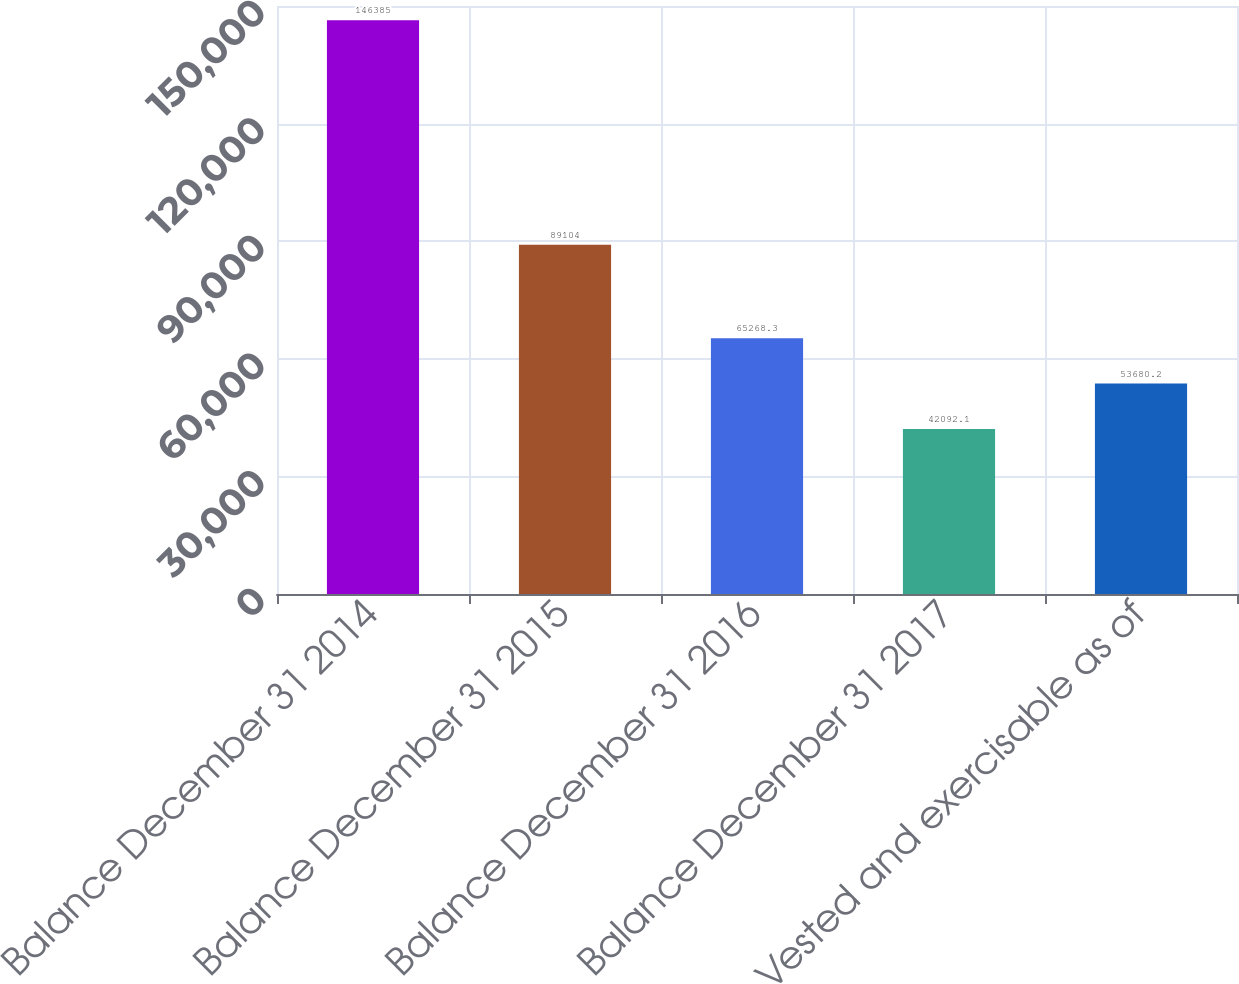<chart> <loc_0><loc_0><loc_500><loc_500><bar_chart><fcel>Balance December 31 2014<fcel>Balance December 31 2015<fcel>Balance December 31 2016<fcel>Balance December 31 2017<fcel>Vested and exercisable as of<nl><fcel>146385<fcel>89104<fcel>65268.3<fcel>42092.1<fcel>53680.2<nl></chart> 